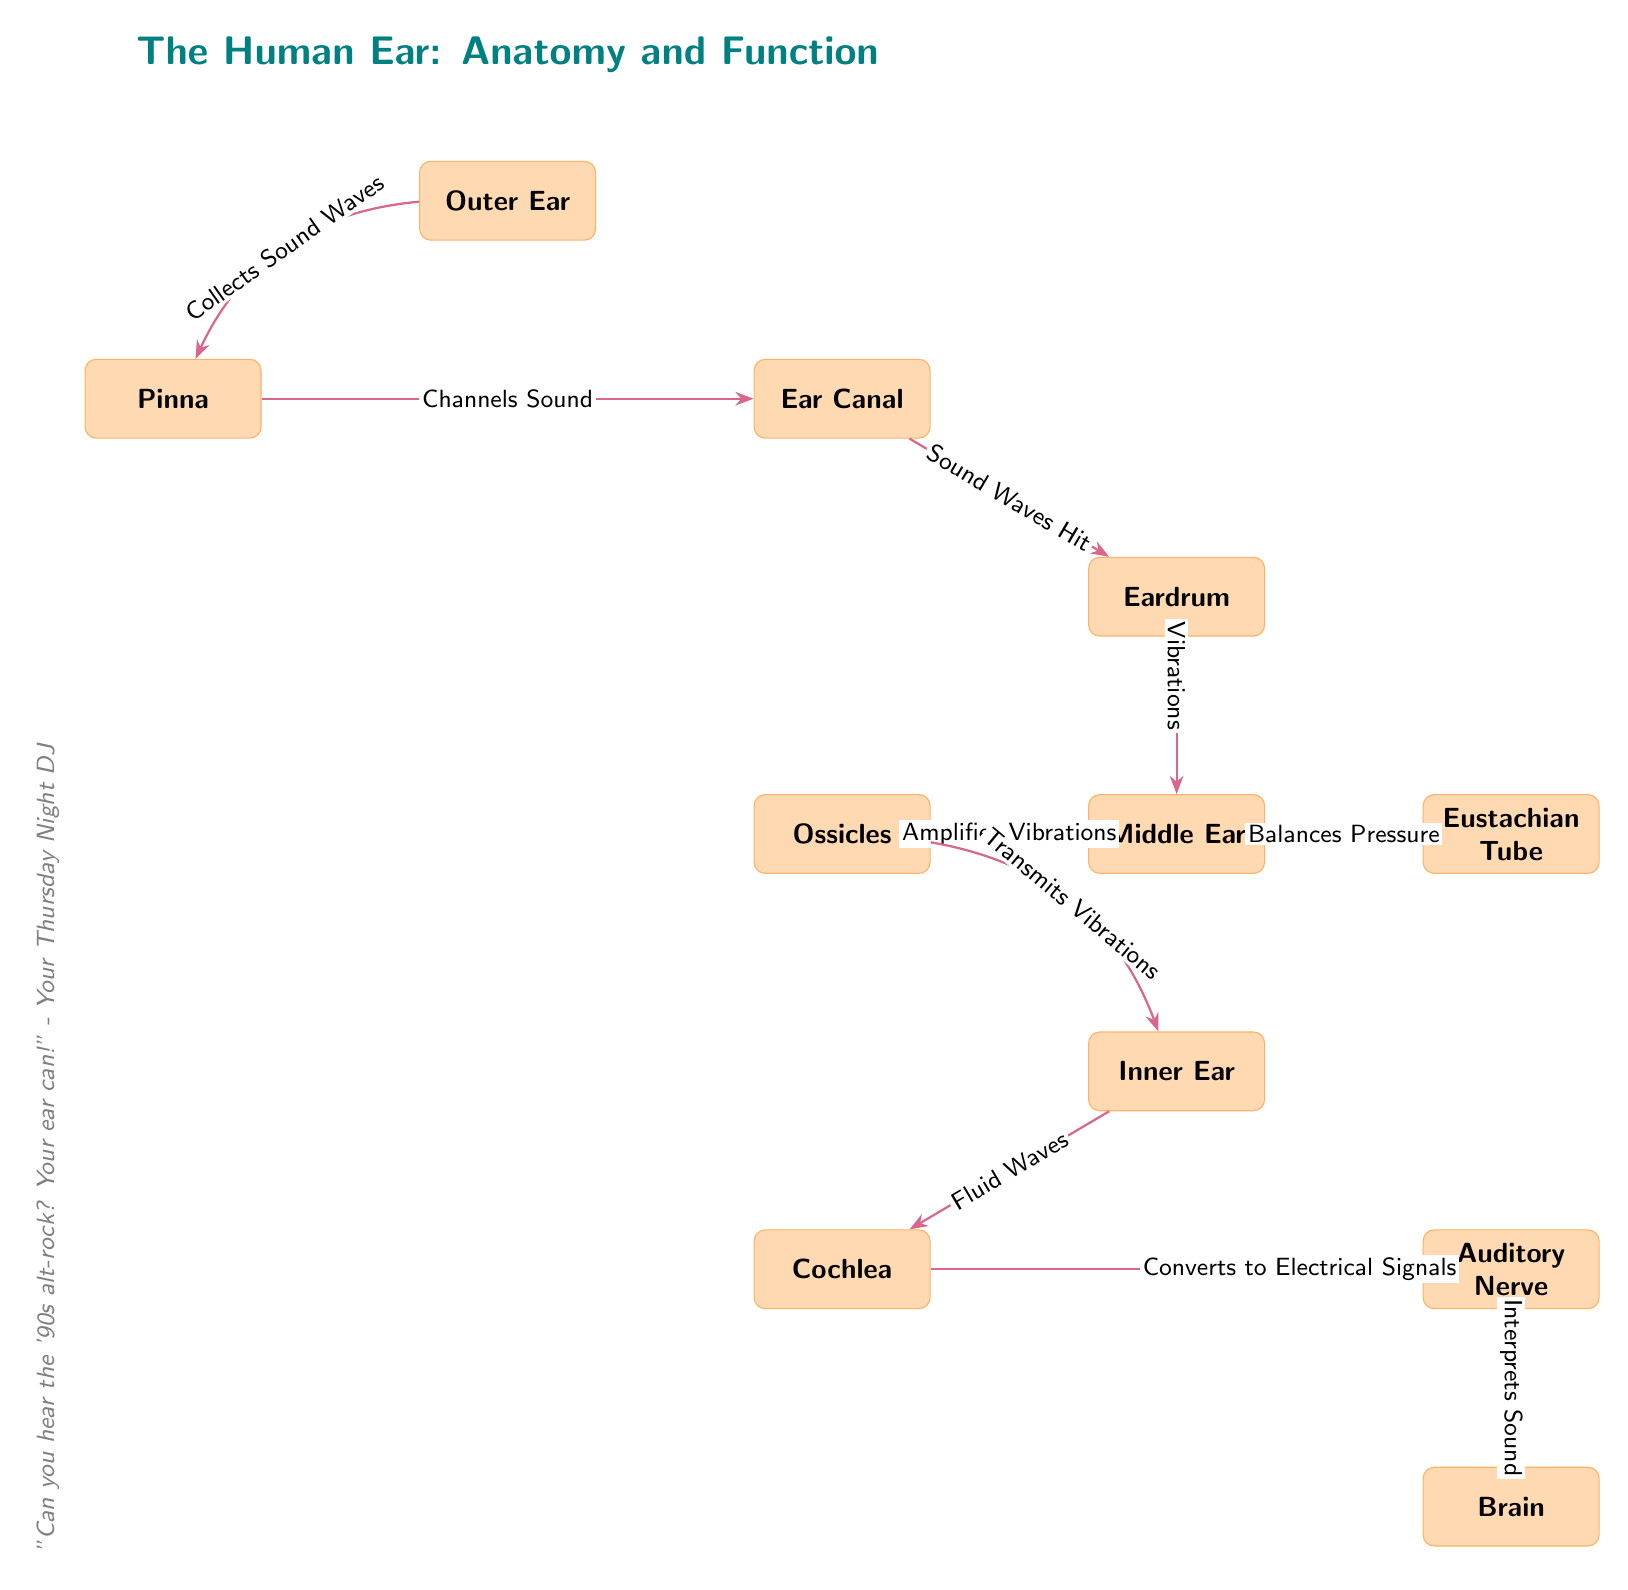What is the top node in the diagram? The top node in the diagram is labeled "The Human Ear: Anatomy and Function," which serves as the title for the visual representation of the ear's structure and function.
Answer: The Human Ear: Anatomy and Function How many main parts are illustrated in the diagram? The diagram illustrates four main parts of the ear: Outer Ear, Middle Ear, Inner Ear, and Brain. There are other components within these parts like the Pinna, Cochlea, etc., but the main parts count to four.
Answer: 4 What is the function associated with the Eardrum? The Eardrum in the diagram is noted for the function of receiving sound waves that create vibrations. It serves as the interface between the outer ear and the middle ear.
Answer: Vibrations What part is responsible for amplifying vibrations? The part responsible for amplifying vibrations is the Ossicles, which are located in the Middle Ear and are indicated to enhance the vibrations received from the Eardrum before they are sent to the Inner Ear.
Answer: Ossicles What is the connection between the Cochlea and the Auditory Nerve in the context of the diagram? The connection between the Cochlea and the Auditory Nerve is characterized by the function of converting fluid waves into electrical signals, which are then transmitted to the Auditory Nerve for further processing.
Answer: Converts to Electrical Signals How does the Middle Ear maintain pressure? The Middle Ear maintains pressure through the Eustachian Tube, which balances the air pressure within the ear, ensuring that the Eardrum can vibrate correctly.
Answer: Balances Pressure What is the final destination of the signals processed by the Auditory Nerve? The final destination of the signals processed by the Auditory Nerve is the Brain, where the sound is interpreted. This flows from the Auditory Nerve to the Brain in the diagram.
Answer: Brain Name one function of the Pinna. The Pinna is responsible for collecting sound waves, which it channels into the Ear Canal, setting off the auditory process.
Answer: Collects Sound Waves What type of signal is transmitted from the Cochlea to the Auditory Nerve? The type of signal transmitted from the Cochlea to the Auditory Nerve is electrical signals, which are essential for the neural representation of sound for the brain.
Answer: Electrical Signals 